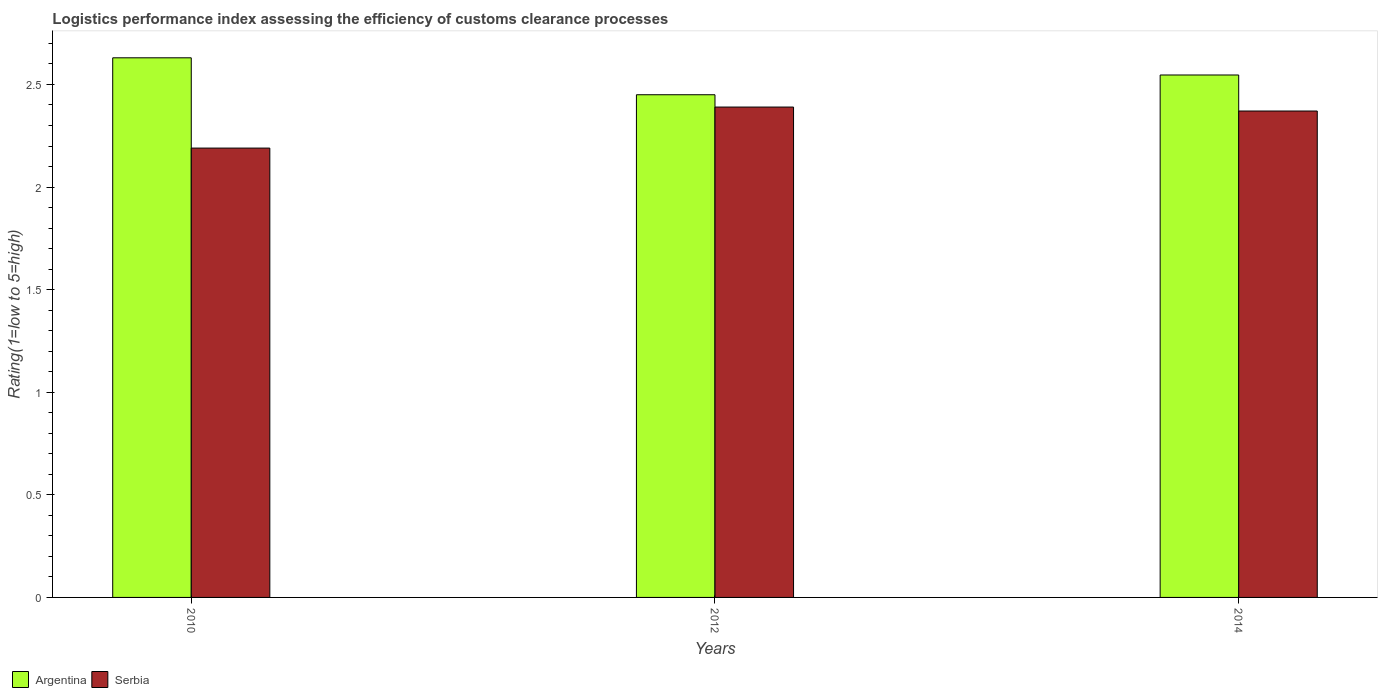How many different coloured bars are there?
Offer a very short reply. 2. How many groups of bars are there?
Provide a short and direct response. 3. Are the number of bars on each tick of the X-axis equal?
Provide a succinct answer. Yes. How many bars are there on the 2nd tick from the right?
Offer a terse response. 2. What is the label of the 2nd group of bars from the left?
Keep it short and to the point. 2012. What is the Logistic performance index in Argentina in 2010?
Ensure brevity in your answer.  2.63. Across all years, what is the maximum Logistic performance index in Argentina?
Offer a terse response. 2.63. Across all years, what is the minimum Logistic performance index in Argentina?
Offer a terse response. 2.45. What is the total Logistic performance index in Argentina in the graph?
Make the answer very short. 7.63. What is the difference between the Logistic performance index in Serbia in 2012 and that in 2014?
Provide a succinct answer. 0.02. What is the difference between the Logistic performance index in Serbia in 2010 and the Logistic performance index in Argentina in 2012?
Provide a short and direct response. -0.26. What is the average Logistic performance index in Argentina per year?
Make the answer very short. 2.54. In the year 2012, what is the difference between the Logistic performance index in Serbia and Logistic performance index in Argentina?
Give a very brief answer. -0.06. In how many years, is the Logistic performance index in Serbia greater than 0.8?
Offer a terse response. 3. What is the ratio of the Logistic performance index in Serbia in 2010 to that in 2012?
Provide a short and direct response. 0.92. Is the difference between the Logistic performance index in Serbia in 2012 and 2014 greater than the difference between the Logistic performance index in Argentina in 2012 and 2014?
Offer a very short reply. Yes. What is the difference between the highest and the second highest Logistic performance index in Serbia?
Your response must be concise. 0.02. What is the difference between the highest and the lowest Logistic performance index in Serbia?
Give a very brief answer. 0.2. What does the 2nd bar from the left in 2014 represents?
Your response must be concise. Serbia. What does the 1st bar from the right in 2012 represents?
Provide a succinct answer. Serbia. How many years are there in the graph?
Provide a succinct answer. 3. Are the values on the major ticks of Y-axis written in scientific E-notation?
Give a very brief answer. No. Does the graph contain any zero values?
Make the answer very short. No. Does the graph contain grids?
Offer a very short reply. No. How many legend labels are there?
Ensure brevity in your answer.  2. How are the legend labels stacked?
Provide a succinct answer. Horizontal. What is the title of the graph?
Make the answer very short. Logistics performance index assessing the efficiency of customs clearance processes. What is the label or title of the Y-axis?
Your answer should be compact. Rating(1=low to 5=high). What is the Rating(1=low to 5=high) in Argentina in 2010?
Provide a short and direct response. 2.63. What is the Rating(1=low to 5=high) in Serbia in 2010?
Your answer should be compact. 2.19. What is the Rating(1=low to 5=high) of Argentina in 2012?
Provide a short and direct response. 2.45. What is the Rating(1=low to 5=high) in Serbia in 2012?
Offer a terse response. 2.39. What is the Rating(1=low to 5=high) of Argentina in 2014?
Make the answer very short. 2.55. What is the Rating(1=low to 5=high) in Serbia in 2014?
Make the answer very short. 2.37. Across all years, what is the maximum Rating(1=low to 5=high) in Argentina?
Make the answer very short. 2.63. Across all years, what is the maximum Rating(1=low to 5=high) in Serbia?
Your answer should be compact. 2.39. Across all years, what is the minimum Rating(1=low to 5=high) in Argentina?
Your response must be concise. 2.45. Across all years, what is the minimum Rating(1=low to 5=high) of Serbia?
Your answer should be very brief. 2.19. What is the total Rating(1=low to 5=high) in Argentina in the graph?
Your answer should be very brief. 7.63. What is the total Rating(1=low to 5=high) of Serbia in the graph?
Give a very brief answer. 6.95. What is the difference between the Rating(1=low to 5=high) of Argentina in 2010 and that in 2012?
Ensure brevity in your answer.  0.18. What is the difference between the Rating(1=low to 5=high) of Argentina in 2010 and that in 2014?
Keep it short and to the point. 0.08. What is the difference between the Rating(1=low to 5=high) of Serbia in 2010 and that in 2014?
Your answer should be compact. -0.18. What is the difference between the Rating(1=low to 5=high) of Argentina in 2012 and that in 2014?
Ensure brevity in your answer.  -0.1. What is the difference between the Rating(1=low to 5=high) of Serbia in 2012 and that in 2014?
Ensure brevity in your answer.  0.02. What is the difference between the Rating(1=low to 5=high) of Argentina in 2010 and the Rating(1=low to 5=high) of Serbia in 2012?
Provide a succinct answer. 0.24. What is the difference between the Rating(1=low to 5=high) of Argentina in 2010 and the Rating(1=low to 5=high) of Serbia in 2014?
Provide a succinct answer. 0.26. What is the difference between the Rating(1=low to 5=high) of Argentina in 2012 and the Rating(1=low to 5=high) of Serbia in 2014?
Provide a succinct answer. 0.08. What is the average Rating(1=low to 5=high) in Argentina per year?
Give a very brief answer. 2.54. What is the average Rating(1=low to 5=high) of Serbia per year?
Offer a very short reply. 2.32. In the year 2010, what is the difference between the Rating(1=low to 5=high) in Argentina and Rating(1=low to 5=high) in Serbia?
Provide a short and direct response. 0.44. In the year 2012, what is the difference between the Rating(1=low to 5=high) of Argentina and Rating(1=low to 5=high) of Serbia?
Ensure brevity in your answer.  0.06. In the year 2014, what is the difference between the Rating(1=low to 5=high) in Argentina and Rating(1=low to 5=high) in Serbia?
Your answer should be compact. 0.18. What is the ratio of the Rating(1=low to 5=high) in Argentina in 2010 to that in 2012?
Your response must be concise. 1.07. What is the ratio of the Rating(1=low to 5=high) in Serbia in 2010 to that in 2012?
Your answer should be compact. 0.92. What is the ratio of the Rating(1=low to 5=high) of Argentina in 2010 to that in 2014?
Provide a short and direct response. 1.03. What is the ratio of the Rating(1=low to 5=high) in Serbia in 2010 to that in 2014?
Your answer should be compact. 0.92. What is the ratio of the Rating(1=low to 5=high) of Argentina in 2012 to that in 2014?
Your answer should be compact. 0.96. What is the ratio of the Rating(1=low to 5=high) of Serbia in 2012 to that in 2014?
Your answer should be compact. 1.01. What is the difference between the highest and the second highest Rating(1=low to 5=high) in Argentina?
Keep it short and to the point. 0.08. What is the difference between the highest and the second highest Rating(1=low to 5=high) of Serbia?
Your response must be concise. 0.02. What is the difference between the highest and the lowest Rating(1=low to 5=high) in Argentina?
Make the answer very short. 0.18. What is the difference between the highest and the lowest Rating(1=low to 5=high) of Serbia?
Keep it short and to the point. 0.2. 